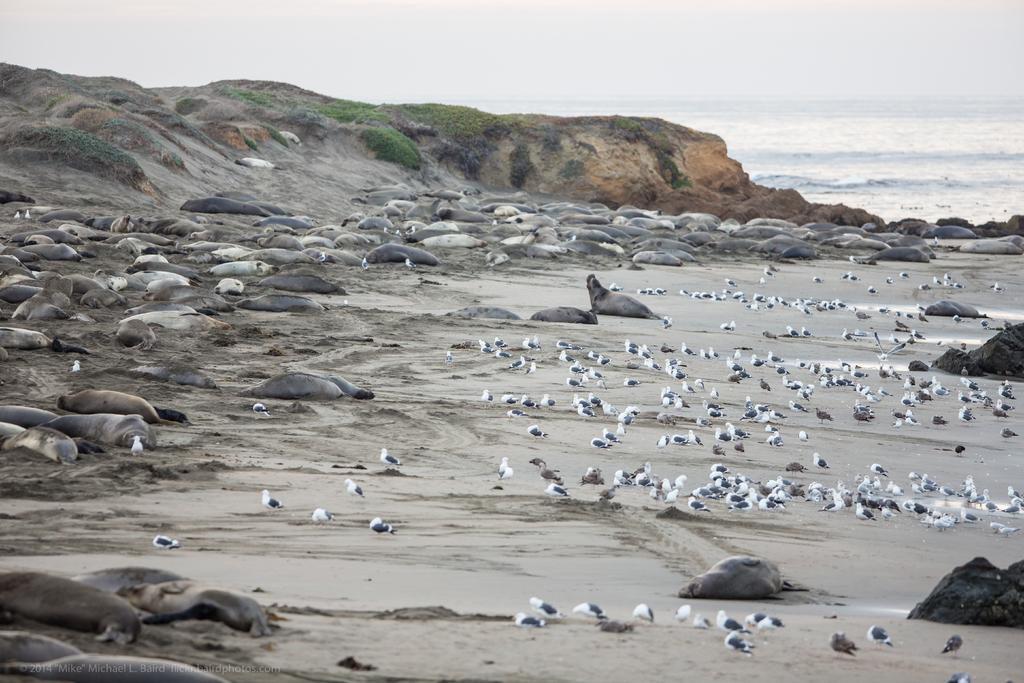What type of environment is shown in the image? The image depicts a sea. What animals can be seen on the sand in the image? There are seals and birds on the sand in the image. What else is visible besides the animals and sand? There is water visible in the image. What can be seen at the top of the image? The sky is visible at the top of the image. Where is the toothbrush located in the image? There is no toothbrush present in the image. Can you tell me how many parcels are being delivered to the store in the image? There is no store or parcel delivery depicted in the image. 